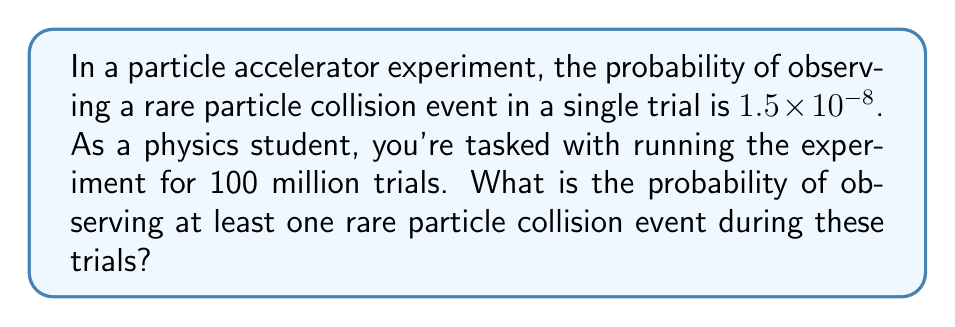Help me with this question. Let's approach this step-by-step:

1) First, we need to recognize that this is a binomial probability problem. However, due to the large number of trials and small probability of success, we can approximate it using the Poisson distribution.

2) The expected number of rare events (λ) is:
   $$\lambda = np = (10^8)(1.5 \times 10^{-8}) = 1.5$$

3) We want to find the probability of at least one event occurring. This is equivalent to 1 minus the probability of no events occurring.

4) The Poisson probability mass function for $X$ events is:
   $$P(X = k) = \frac{e^{-\lambda}\lambda^k}{k!}$$

5) For zero events:
   $$P(X = 0) = \frac{e^{-1.5}(1.5)^0}{0!} = e^{-1.5}$$

6) Therefore, the probability of at least one event is:
   $$P(X \geq 1) = 1 - P(X = 0) = 1 - e^{-1.5}$$

7) Calculating this:
   $$1 - e^{-1.5} \approx 0.7769$$

Thus, the probability of observing at least one rare particle collision event is approximately 0.7769 or 77.69%.
Answer: $1 - e^{-1.5} \approx 0.7769$ 